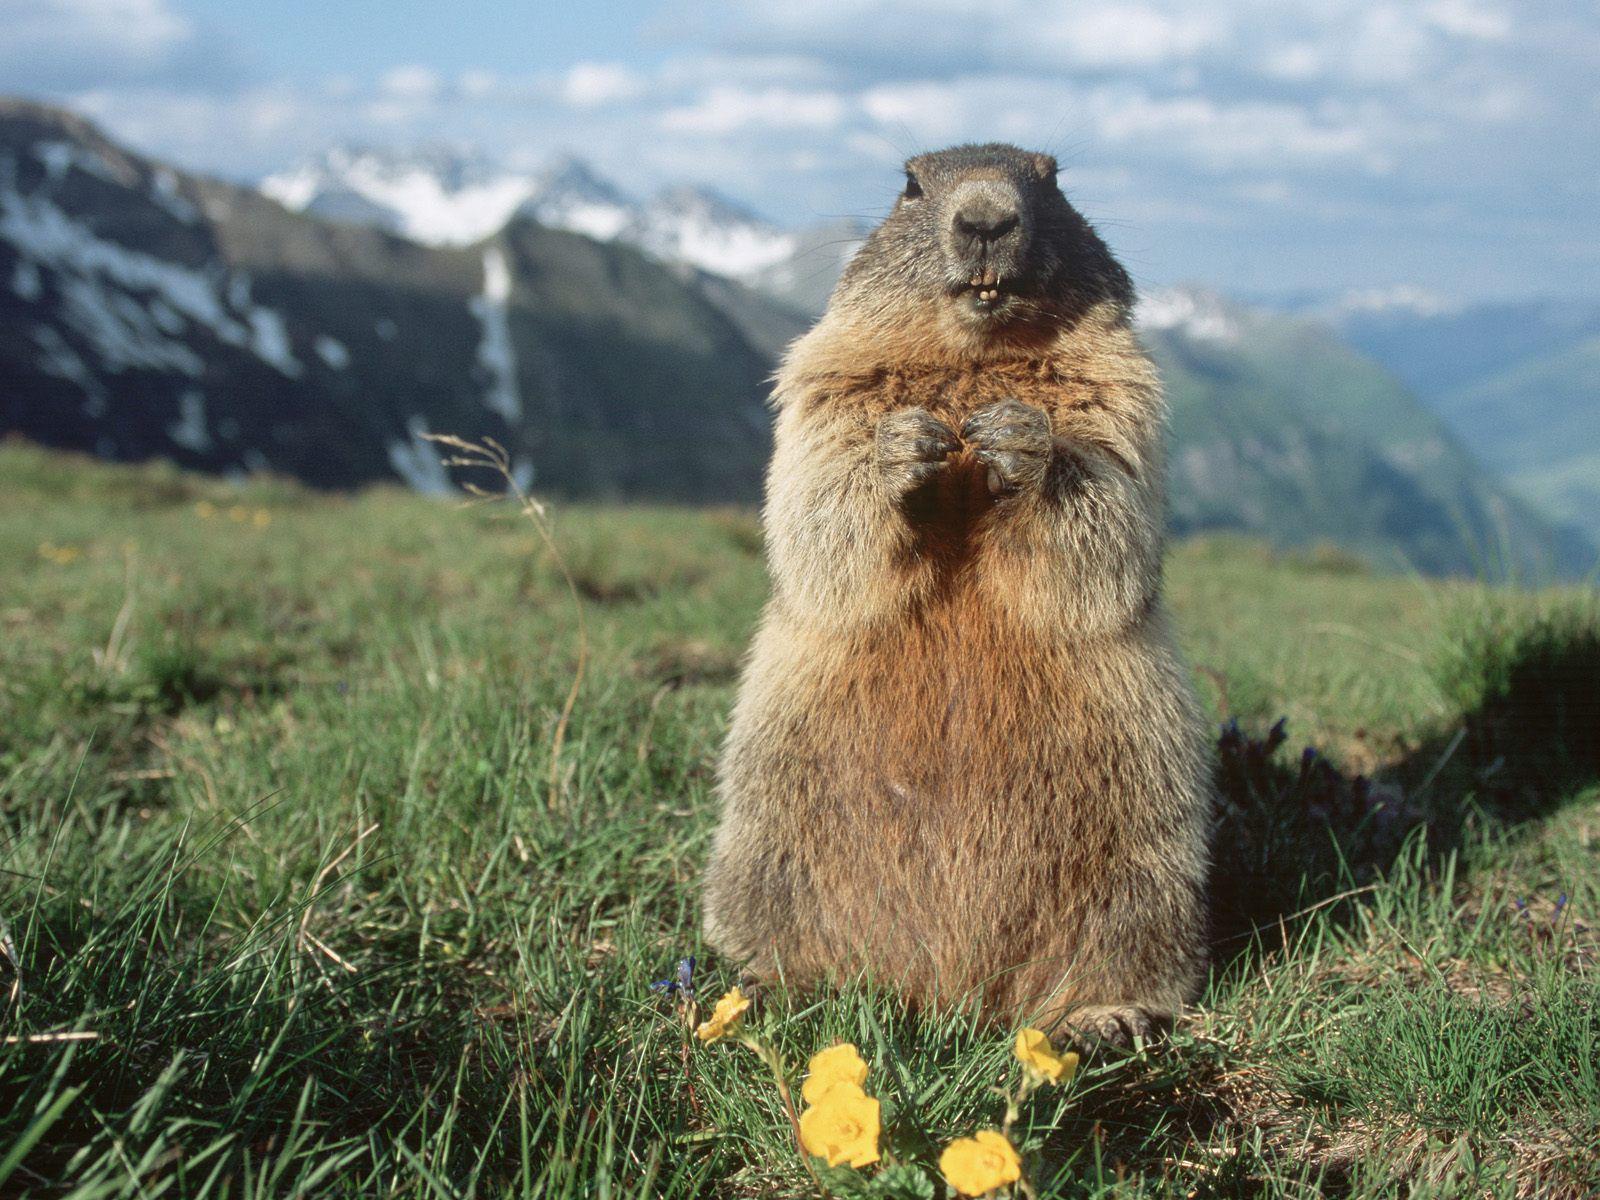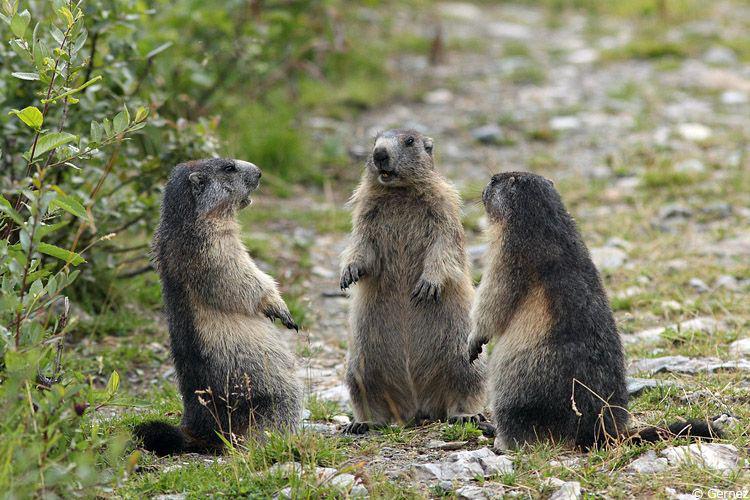The first image is the image on the left, the second image is the image on the right. Analyze the images presented: Is the assertion "The left and right image contains the same number of groundhogs with at least one sitting on their butt." valid? Answer yes or no. No. The first image is the image on the left, the second image is the image on the right. Given the left and right images, does the statement "All marmots shown are standing up on their hind legs, and one image shows a single marmot facing forward." hold true? Answer yes or no. Yes. 